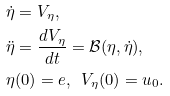<formula> <loc_0><loc_0><loc_500><loc_500>\dot { \eta } & = V _ { \eta } , \\ \ddot { \eta } & = \frac { d V _ { \eta } } { d t } = { \mathcal { B } } ( \eta , \dot { \eta } ) , \\ \eta & ( 0 ) = e , \ \ V _ { \eta } ( 0 ) = u _ { 0 } .</formula> 